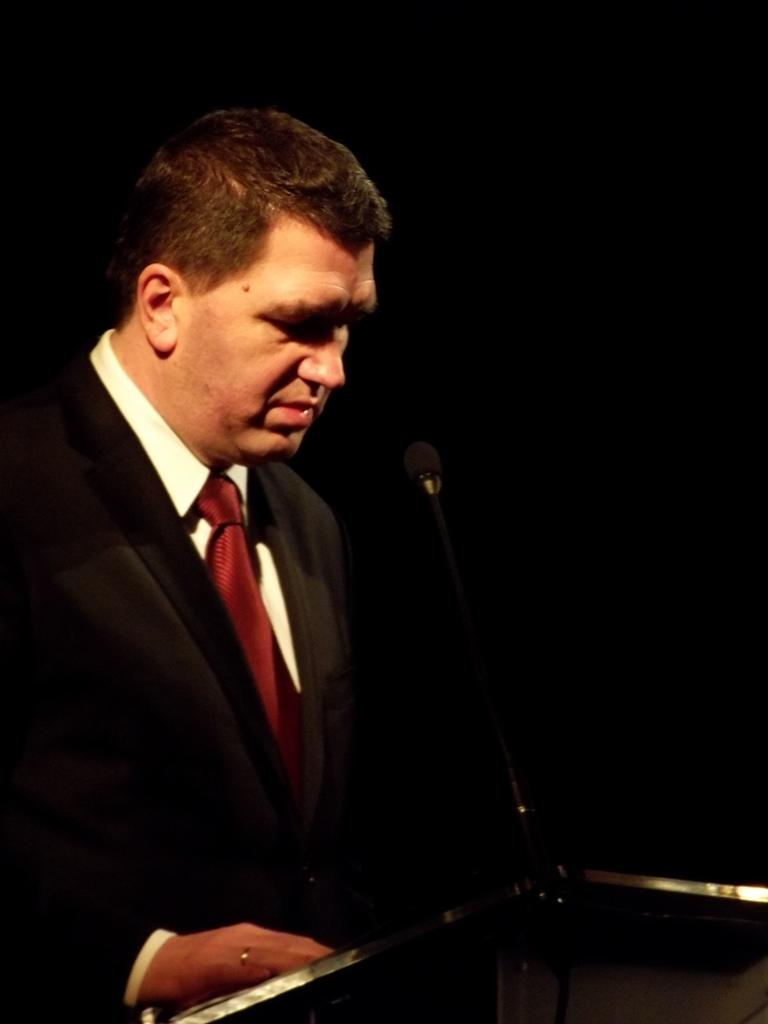Who or what is in the image? There is a person in the image. What is the person wearing? The person is wearing a black suit. What can be seen behind the person? The person is standing in front of a podium. What is on the podium? There is a microphone on the podium. What color is the background of the image? The background of the image is black. Can you see any tin or sheet in the image? There is no tin or sheet present in the image. Is there a cow visible in the image? There is no cow present in the image. 